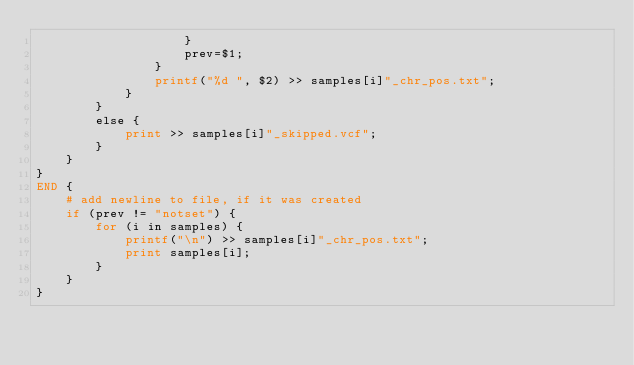<code> <loc_0><loc_0><loc_500><loc_500><_Awk_>                    }
                    prev=$1;
                }
                printf("%d ", $2) >> samples[i]"_chr_pos.txt";
            }
        }
        else {
            print >> samples[i]"_skipped.vcf";
        }
    }
}
END {
    # add newline to file, if it was created
    if (prev != "notset") {
        for (i in samples) {
            printf("\n") >> samples[i]"_chr_pos.txt";
            print samples[i];
        }
    }
}
</code> 